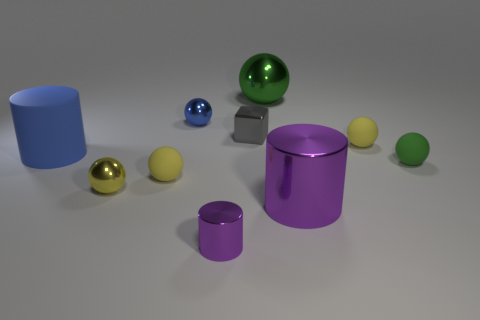There is a tiny metal thing that is left of the small sphere behind the small cube; is there a small shiny thing that is in front of it?
Offer a very short reply. Yes. There is a thing behind the small blue ball; is its color the same as the big thing that is on the right side of the green metal ball?
Your answer should be very brief. No. What material is the green sphere that is the same size as the blue cylinder?
Provide a succinct answer. Metal. What is the size of the thing to the left of the tiny metal ball that is to the left of the small blue shiny object that is behind the small green thing?
Keep it short and to the point. Large. What number of other objects are there of the same material as the small cylinder?
Your answer should be very brief. 5. How big is the matte ball behind the big matte object?
Make the answer very short. Small. What number of objects are right of the big rubber cylinder and behind the tiny purple metal cylinder?
Your answer should be very brief. 8. What material is the large cylinder that is on the right side of the small metal ball that is in front of the gray shiny thing?
Offer a very short reply. Metal. What is the material of the tiny green thing that is the same shape as the yellow metal object?
Offer a terse response. Rubber. Is there a big gray rubber object?
Your answer should be very brief. No. 